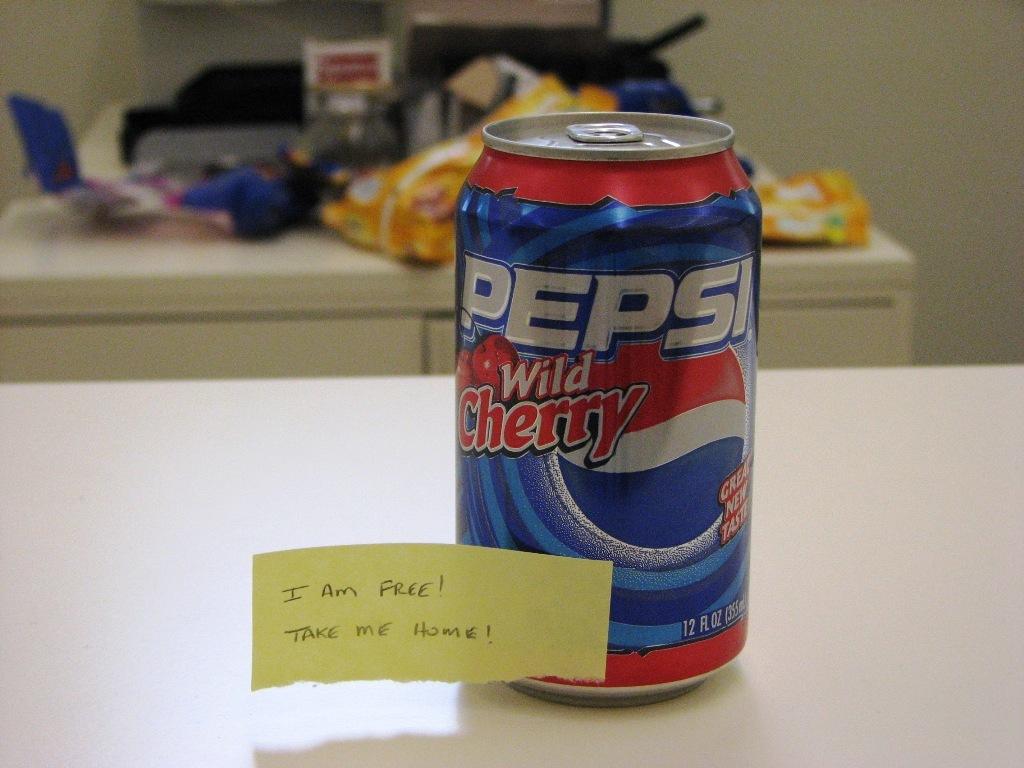What kind of cherry is the pepsi?
Your response must be concise. Wild. How much is the can of soda?
Your answer should be compact. Free. 